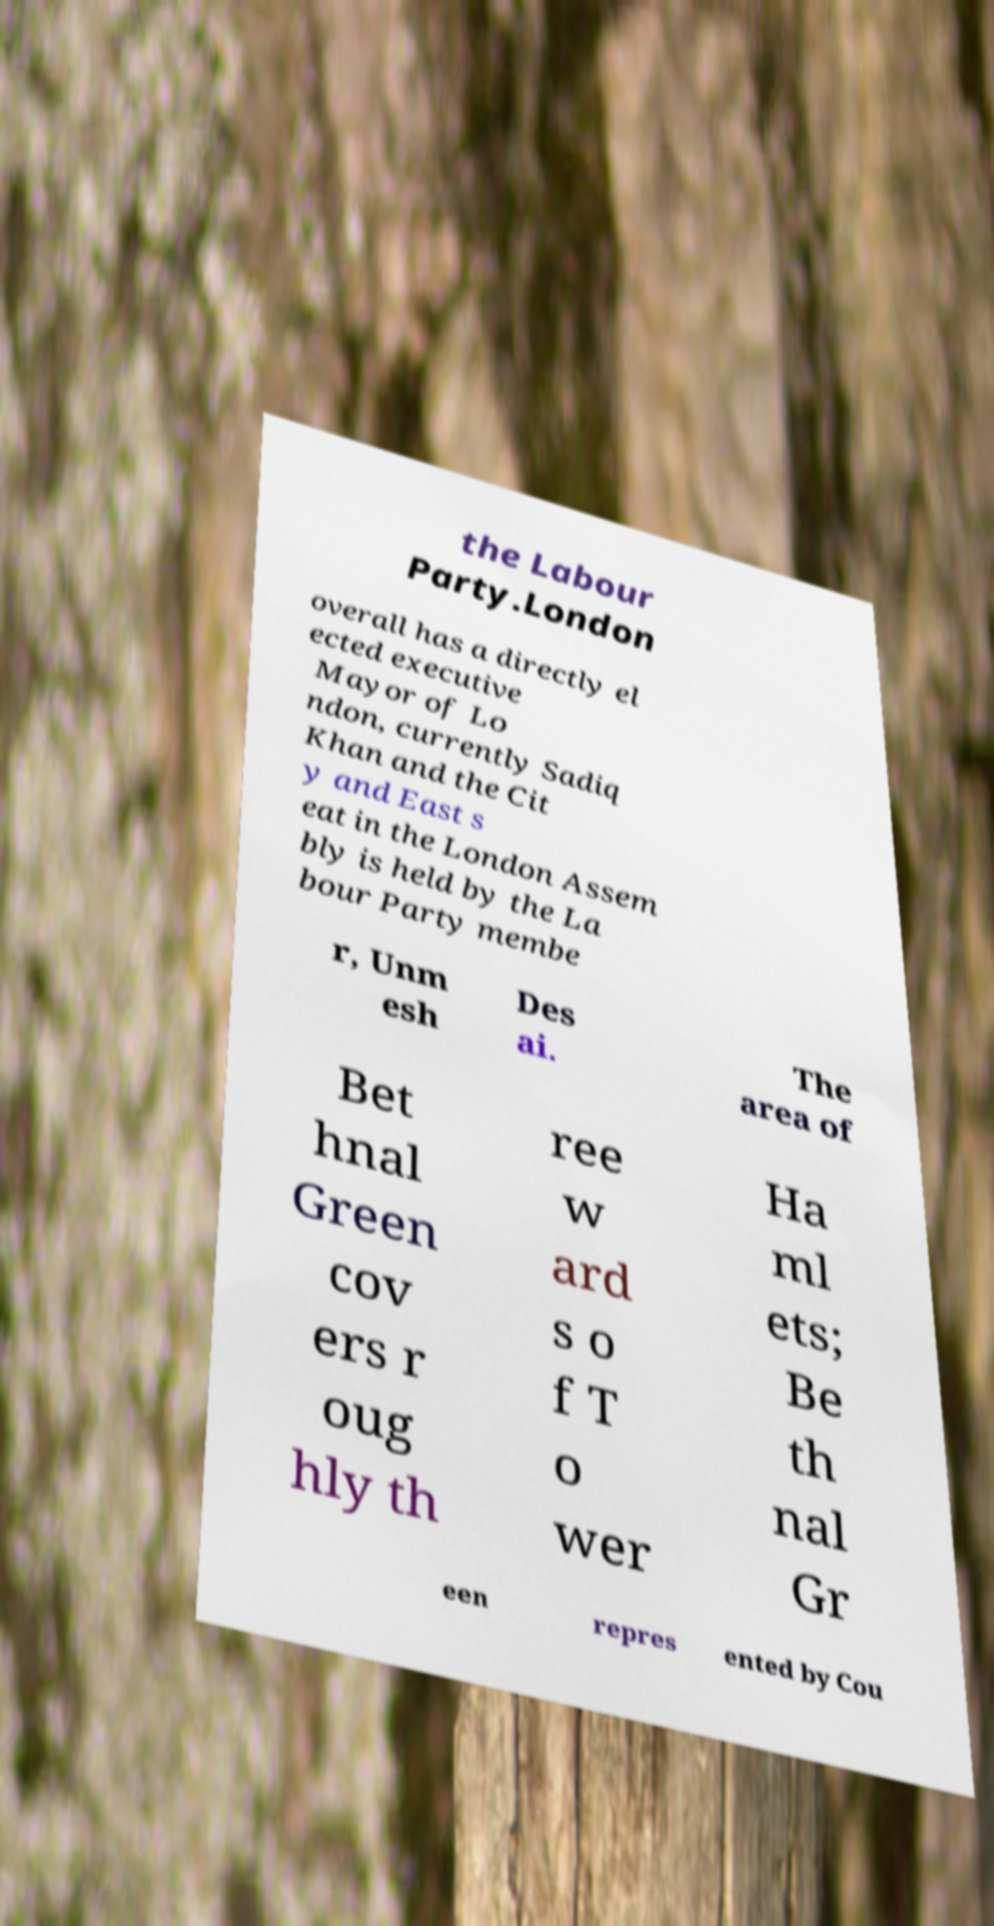Could you assist in decoding the text presented in this image and type it out clearly? the Labour Party.London overall has a directly el ected executive Mayor of Lo ndon, currently Sadiq Khan and the Cit y and East s eat in the London Assem bly is held by the La bour Party membe r, Unm esh Des ai. The area of Bet hnal Green cov ers r oug hly th ree w ard s o f T o wer Ha ml ets; Be th nal Gr een repres ented by Cou 